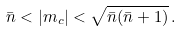Convert formula to latex. <formula><loc_0><loc_0><loc_500><loc_500>\bar { n } < | m _ { c } | < \sqrt { \bar { n } ( \bar { n } + 1 ) } \, .</formula> 